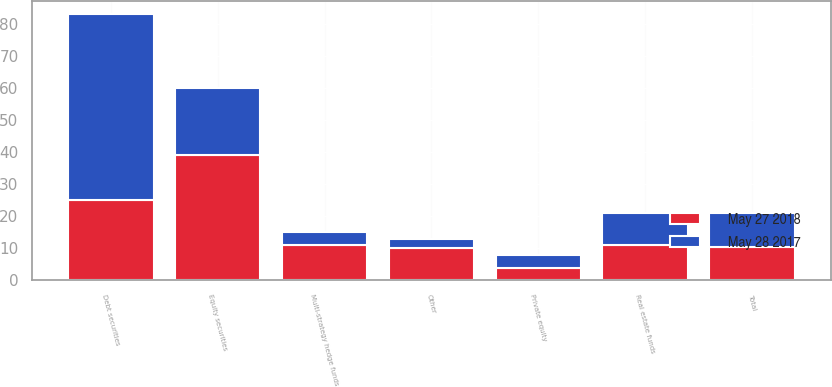Convert chart to OTSL. <chart><loc_0><loc_0><loc_500><loc_500><stacked_bar_chart><ecel><fcel>Equity securities<fcel>Debt securities<fcel>Real estate funds<fcel>Multi-strategy hedge funds<fcel>Private equity<fcel>Other<fcel>Total<nl><fcel>May 28 2017<fcel>21<fcel>58<fcel>10<fcel>4<fcel>4<fcel>3<fcel>10.5<nl><fcel>May 27 2018<fcel>39<fcel>25<fcel>11<fcel>11<fcel>4<fcel>10<fcel>10.5<nl></chart> 